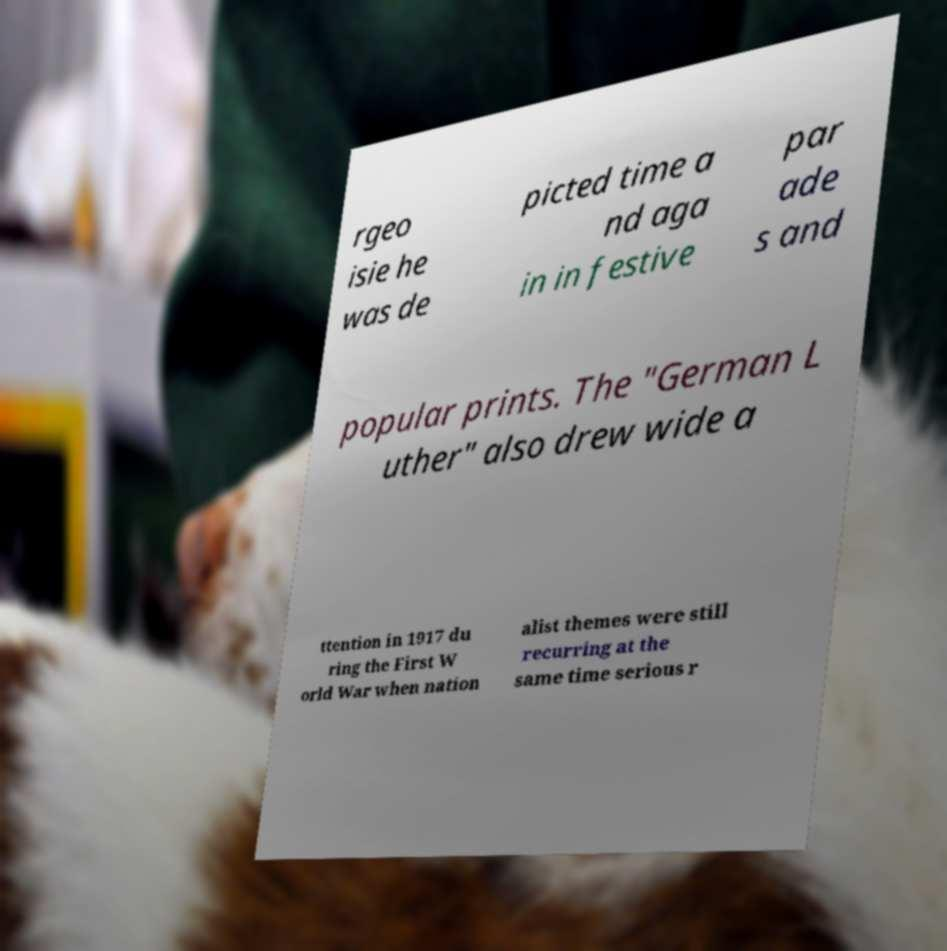What messages or text are displayed in this image? I need them in a readable, typed format. rgeo isie he was de picted time a nd aga in in festive par ade s and popular prints. The "German L uther" also drew wide a ttention in 1917 du ring the First W orld War when nation alist themes were still recurring at the same time serious r 